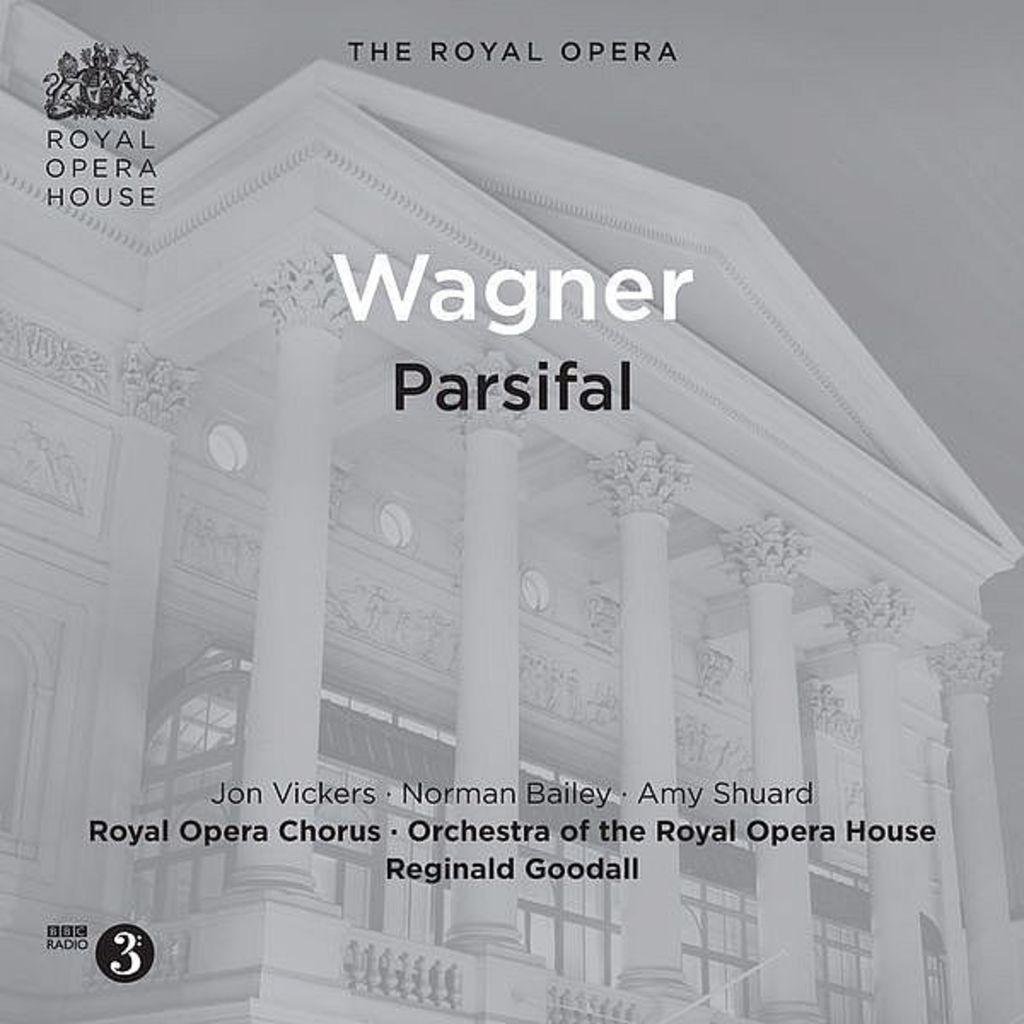What is the main object in the image? There is a poster in the image. What elements are present on the poster? The poster contains logos, text, and a picture of a building. How many crates are stacked behind the text on the poster? There are no crates present in the image. What type of riddle is depicted on the poster? There is no riddle present on the poster; it contains logos, text, and a picture of a building. 